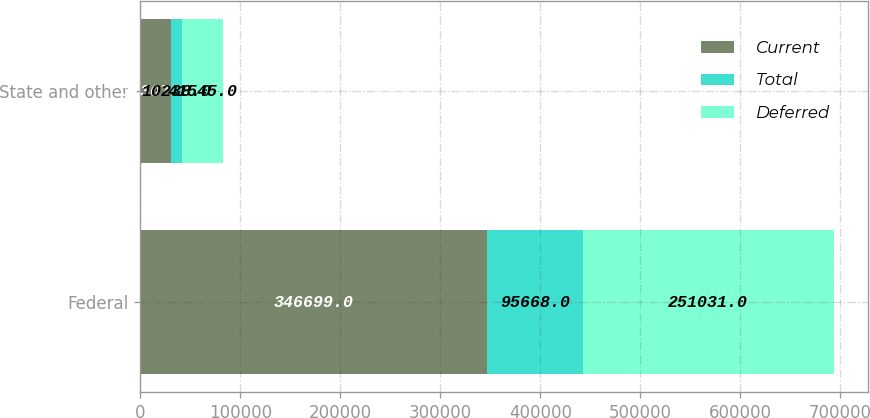Convert chart to OTSL. <chart><loc_0><loc_0><loc_500><loc_500><stacked_bar_chart><ecel><fcel>Federal<fcel>State and other<nl><fcel>Current<fcel>346699<fcel>31307<nl><fcel>Total<fcel>95668<fcel>10238<nl><fcel>Deferred<fcel>251031<fcel>41545<nl></chart> 